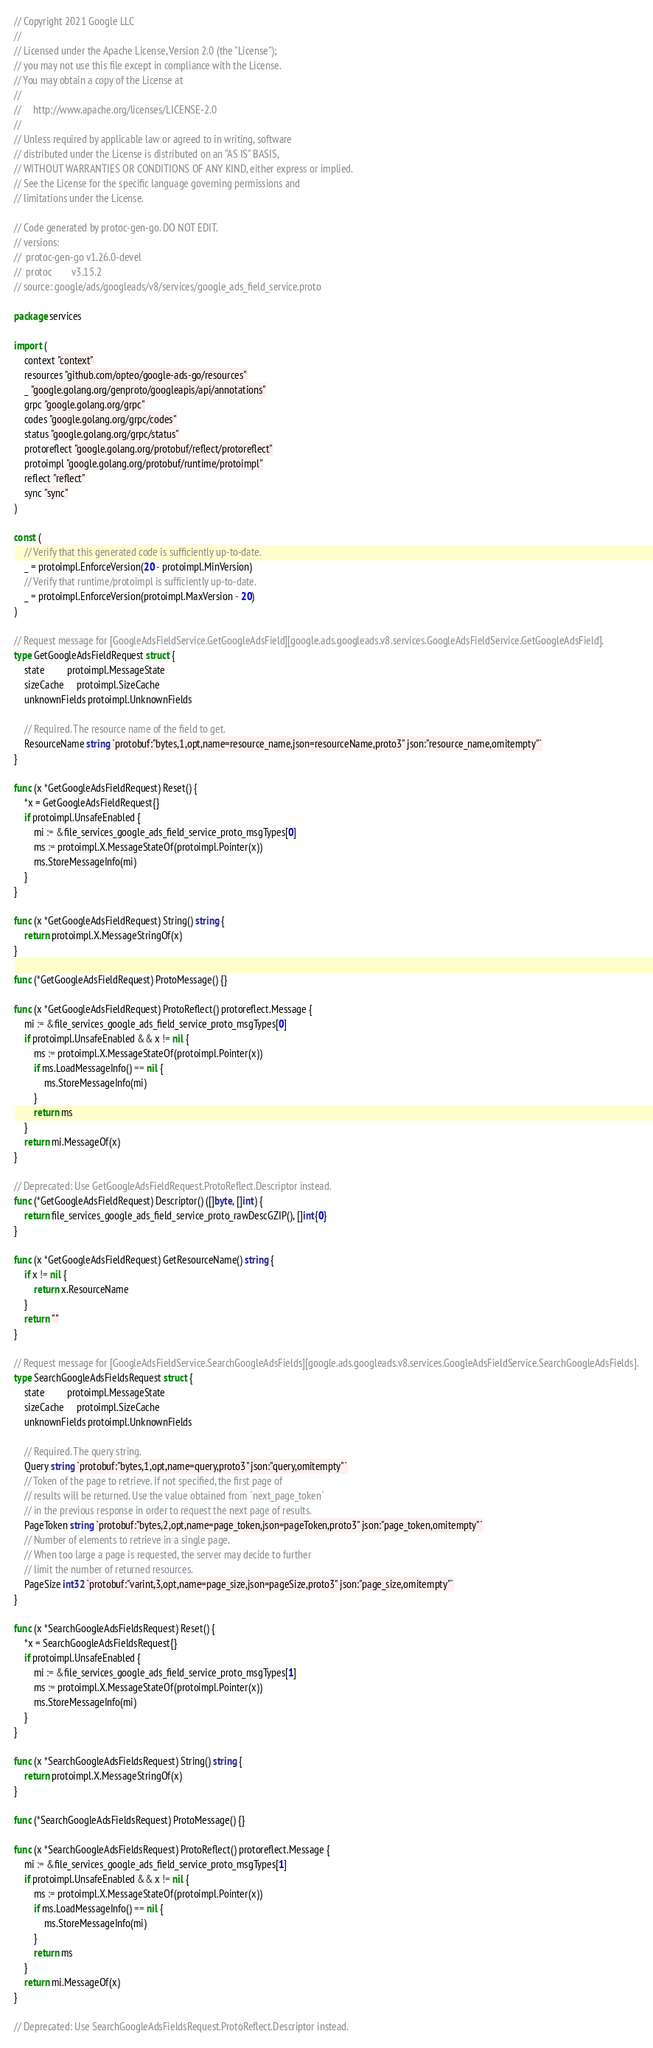Convert code to text. <code><loc_0><loc_0><loc_500><loc_500><_Go_>// Copyright 2021 Google LLC
//
// Licensed under the Apache License, Version 2.0 (the "License");
// you may not use this file except in compliance with the License.
// You may obtain a copy of the License at
//
//     http://www.apache.org/licenses/LICENSE-2.0
//
// Unless required by applicable law or agreed to in writing, software
// distributed under the License is distributed on an "AS IS" BASIS,
// WITHOUT WARRANTIES OR CONDITIONS OF ANY KIND, either express or implied.
// See the License for the specific language governing permissions and
// limitations under the License.

// Code generated by protoc-gen-go. DO NOT EDIT.
// versions:
// 	protoc-gen-go v1.26.0-devel
// 	protoc        v3.15.2
// source: google/ads/googleads/v8/services/google_ads_field_service.proto

package services

import (
	context "context"
	resources "github.com/opteo/google-ads-go/resources"
	_ "google.golang.org/genproto/googleapis/api/annotations"
	grpc "google.golang.org/grpc"
	codes "google.golang.org/grpc/codes"
	status "google.golang.org/grpc/status"
	protoreflect "google.golang.org/protobuf/reflect/protoreflect"
	protoimpl "google.golang.org/protobuf/runtime/protoimpl"
	reflect "reflect"
	sync "sync"
)

const (
	// Verify that this generated code is sufficiently up-to-date.
	_ = protoimpl.EnforceVersion(20 - protoimpl.MinVersion)
	// Verify that runtime/protoimpl is sufficiently up-to-date.
	_ = protoimpl.EnforceVersion(protoimpl.MaxVersion - 20)
)

// Request message for [GoogleAdsFieldService.GetGoogleAdsField][google.ads.googleads.v8.services.GoogleAdsFieldService.GetGoogleAdsField].
type GetGoogleAdsFieldRequest struct {
	state         protoimpl.MessageState
	sizeCache     protoimpl.SizeCache
	unknownFields protoimpl.UnknownFields

	// Required. The resource name of the field to get.
	ResourceName string `protobuf:"bytes,1,opt,name=resource_name,json=resourceName,proto3" json:"resource_name,omitempty"`
}

func (x *GetGoogleAdsFieldRequest) Reset() {
	*x = GetGoogleAdsFieldRequest{}
	if protoimpl.UnsafeEnabled {
		mi := &file_services_google_ads_field_service_proto_msgTypes[0]
		ms := protoimpl.X.MessageStateOf(protoimpl.Pointer(x))
		ms.StoreMessageInfo(mi)
	}
}

func (x *GetGoogleAdsFieldRequest) String() string {
	return protoimpl.X.MessageStringOf(x)
}

func (*GetGoogleAdsFieldRequest) ProtoMessage() {}

func (x *GetGoogleAdsFieldRequest) ProtoReflect() protoreflect.Message {
	mi := &file_services_google_ads_field_service_proto_msgTypes[0]
	if protoimpl.UnsafeEnabled && x != nil {
		ms := protoimpl.X.MessageStateOf(protoimpl.Pointer(x))
		if ms.LoadMessageInfo() == nil {
			ms.StoreMessageInfo(mi)
		}
		return ms
	}
	return mi.MessageOf(x)
}

// Deprecated: Use GetGoogleAdsFieldRequest.ProtoReflect.Descriptor instead.
func (*GetGoogleAdsFieldRequest) Descriptor() ([]byte, []int) {
	return file_services_google_ads_field_service_proto_rawDescGZIP(), []int{0}
}

func (x *GetGoogleAdsFieldRequest) GetResourceName() string {
	if x != nil {
		return x.ResourceName
	}
	return ""
}

// Request message for [GoogleAdsFieldService.SearchGoogleAdsFields][google.ads.googleads.v8.services.GoogleAdsFieldService.SearchGoogleAdsFields].
type SearchGoogleAdsFieldsRequest struct {
	state         protoimpl.MessageState
	sizeCache     protoimpl.SizeCache
	unknownFields protoimpl.UnknownFields

	// Required. The query string.
	Query string `protobuf:"bytes,1,opt,name=query,proto3" json:"query,omitempty"`
	// Token of the page to retrieve. If not specified, the first page of
	// results will be returned. Use the value obtained from `next_page_token`
	// in the previous response in order to request the next page of results.
	PageToken string `protobuf:"bytes,2,opt,name=page_token,json=pageToken,proto3" json:"page_token,omitempty"`
	// Number of elements to retrieve in a single page.
	// When too large a page is requested, the server may decide to further
	// limit the number of returned resources.
	PageSize int32 `protobuf:"varint,3,opt,name=page_size,json=pageSize,proto3" json:"page_size,omitempty"`
}

func (x *SearchGoogleAdsFieldsRequest) Reset() {
	*x = SearchGoogleAdsFieldsRequest{}
	if protoimpl.UnsafeEnabled {
		mi := &file_services_google_ads_field_service_proto_msgTypes[1]
		ms := protoimpl.X.MessageStateOf(protoimpl.Pointer(x))
		ms.StoreMessageInfo(mi)
	}
}

func (x *SearchGoogleAdsFieldsRequest) String() string {
	return protoimpl.X.MessageStringOf(x)
}

func (*SearchGoogleAdsFieldsRequest) ProtoMessage() {}

func (x *SearchGoogleAdsFieldsRequest) ProtoReflect() protoreflect.Message {
	mi := &file_services_google_ads_field_service_proto_msgTypes[1]
	if protoimpl.UnsafeEnabled && x != nil {
		ms := protoimpl.X.MessageStateOf(protoimpl.Pointer(x))
		if ms.LoadMessageInfo() == nil {
			ms.StoreMessageInfo(mi)
		}
		return ms
	}
	return mi.MessageOf(x)
}

// Deprecated: Use SearchGoogleAdsFieldsRequest.ProtoReflect.Descriptor instead.</code> 